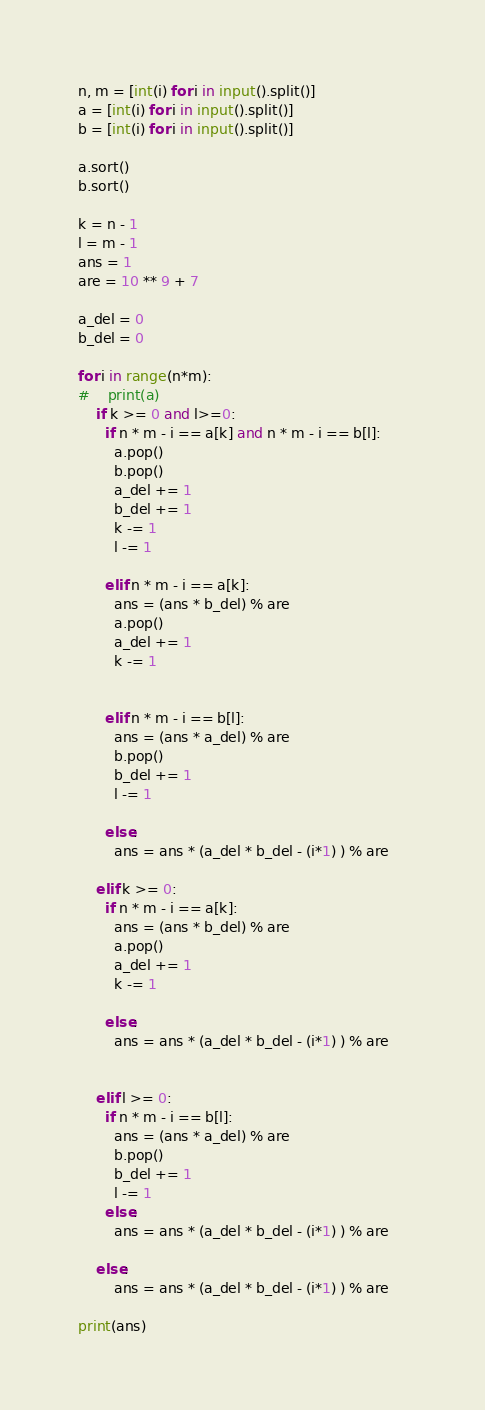Convert code to text. <code><loc_0><loc_0><loc_500><loc_500><_Python_>n, m = [int(i) for i in input().split()]
a = [int(i) for i in input().split()]
b = [int(i) for i in input().split()]

a.sort()
b.sort()

k = n - 1
l = m - 1
ans = 1
are = 10 ** 9 + 7

a_del = 0
b_del = 0

for i in range(n*m):
#    print(a)
    if k >= 0 and l>=0:
      if n * m - i == a[k] and n * m - i == b[l]:
        a.pop()
        b.pop()
        a_del += 1
        b_del += 1
        k -= 1
        l -= 1
        
      elif n * m - i == a[k]:
        ans = (ans * b_del) % are
        a.pop()
        a_del += 1
        k -= 1 

       
      elif n * m - i == b[l]:
        ans = (ans * a_del) % are      
        b.pop()
        b_del += 1       
        l -= 1    

      else:
        ans = ans * (a_del * b_del - (i*1) ) % are

    elif k >= 0:
      if n * m - i == a[k]:
        ans = (ans * b_del) % are
        a.pop()
        a_del += 1
        k -= 1 

      else:
        ans = ans * (a_del * b_del - (i*1) ) % are


    elif l >= 0:
      if n * m - i == b[l]:
        ans = (ans * a_del) % are      
        b.pop()
        b_del += 1       
        l -= 1    
      else:
        ans = ans * (a_del * b_del - (i*1) ) % are

    else:
        ans = ans * (a_del * b_del - (i*1) ) % are    
        
print(ans)</code> 